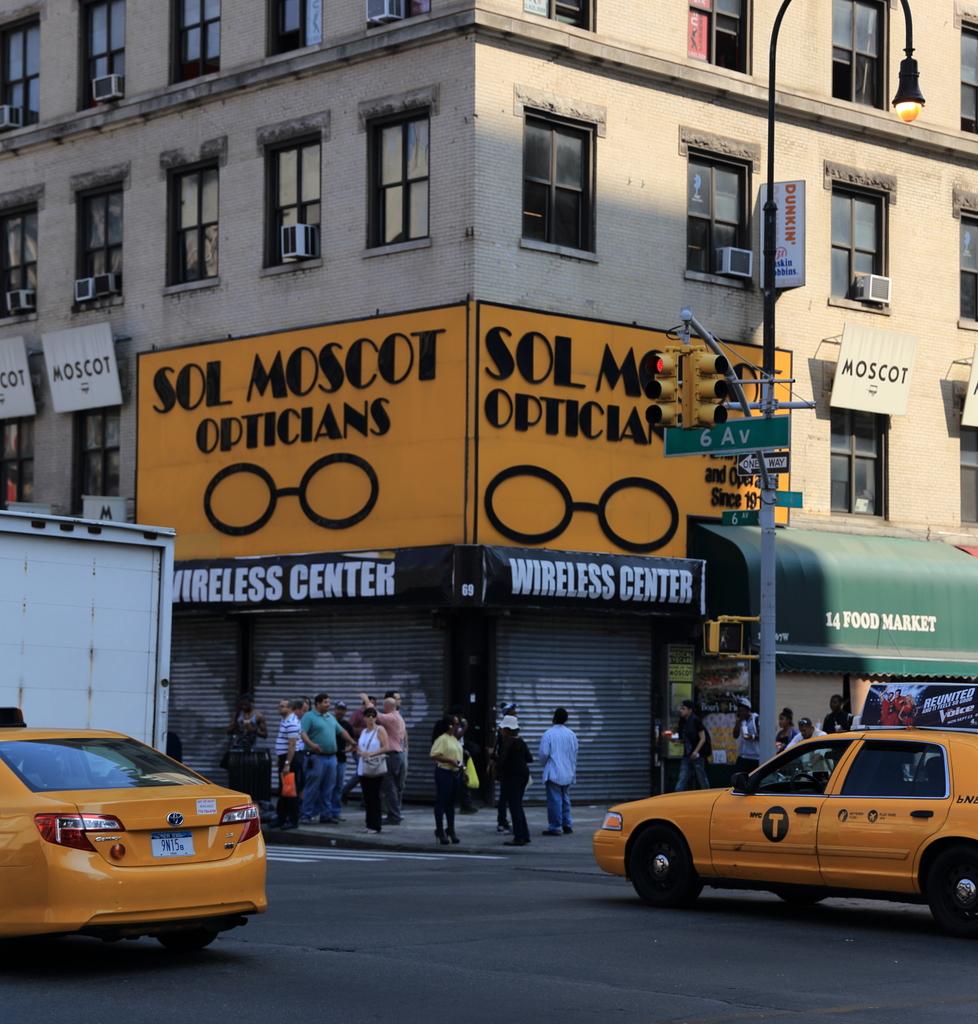What is the name of the opticians?
Your answer should be compact. Sol moscot. What kind of center is this?
Give a very brief answer. Wireless. 